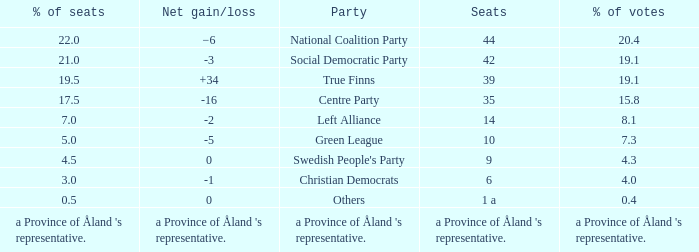When the Swedish People's Party had a net gain/loss of 0, how many seats did they have? 9.0. 